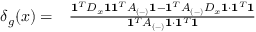<formula> <loc_0><loc_0><loc_500><loc_500>\begin{array} { r l } { \delta _ { g } ( x ) = } & \frac { 1 ^ { T } D _ { x } 1 1 ^ { T } A _ { ( - ) } 1 - 1 ^ { T } A _ { ( - ) } D _ { x } 1 \cdot 1 ^ { T } 1 } { 1 ^ { T } A _ { ( - ) } 1 \cdot 1 ^ { T } 1 } } \end{array}</formula> 